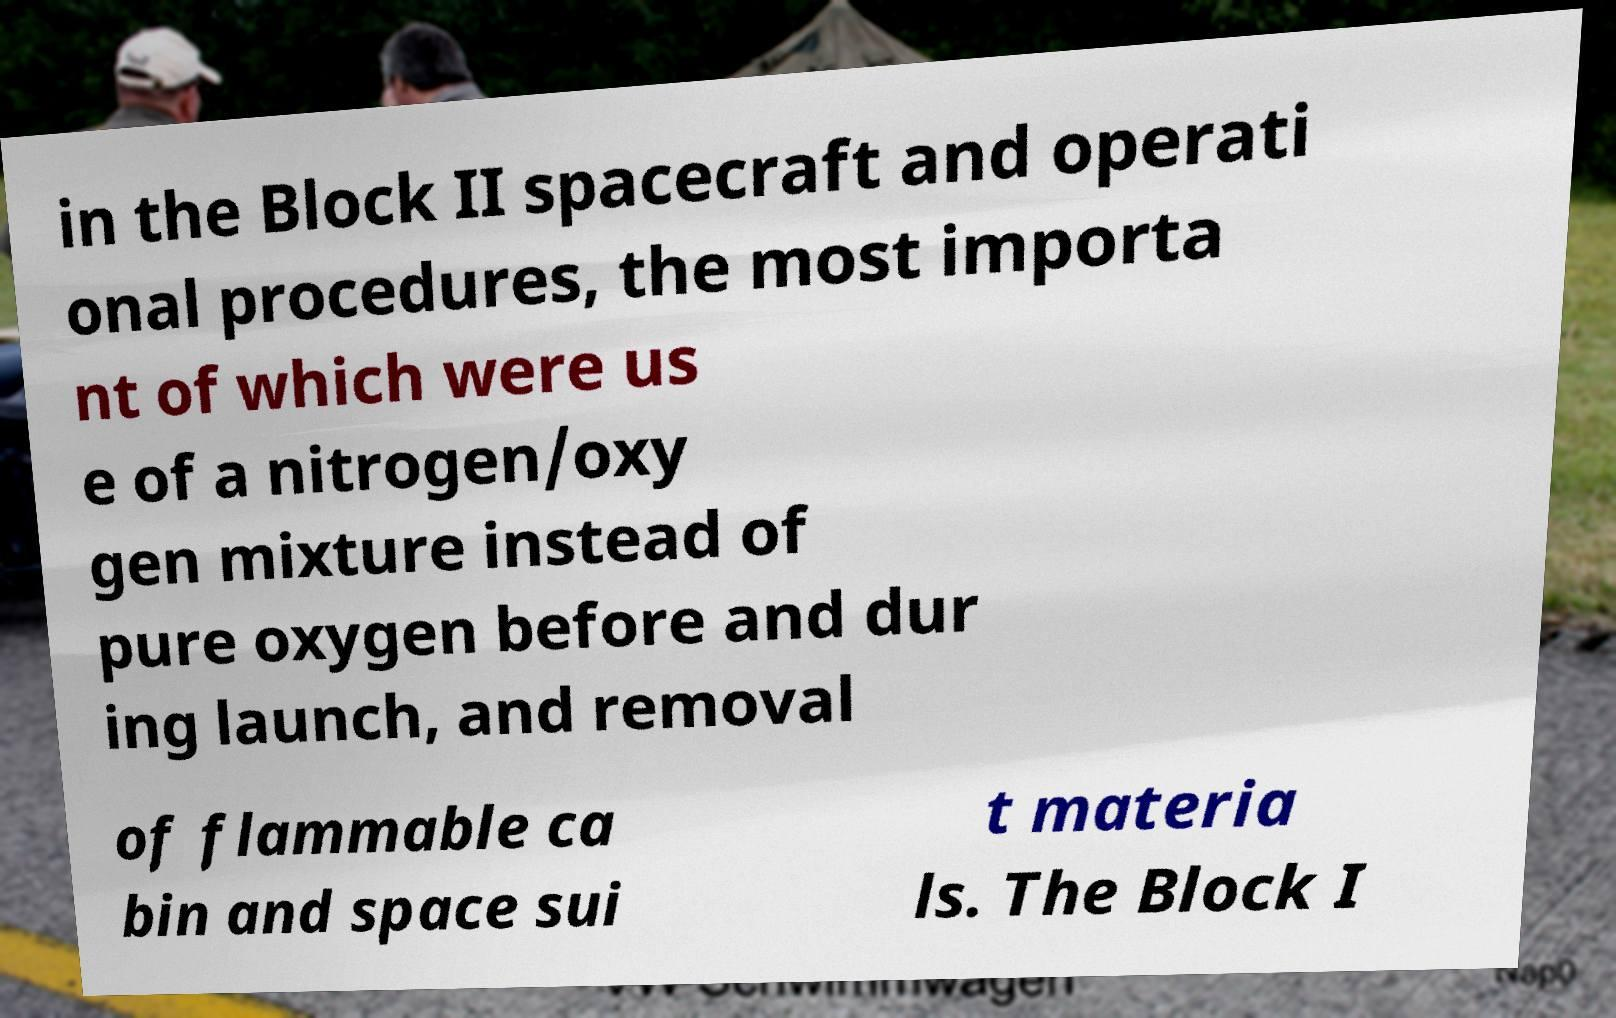Please identify and transcribe the text found in this image. in the Block II spacecraft and operati onal procedures, the most importa nt of which were us e of a nitrogen/oxy gen mixture instead of pure oxygen before and dur ing launch, and removal of flammable ca bin and space sui t materia ls. The Block I 